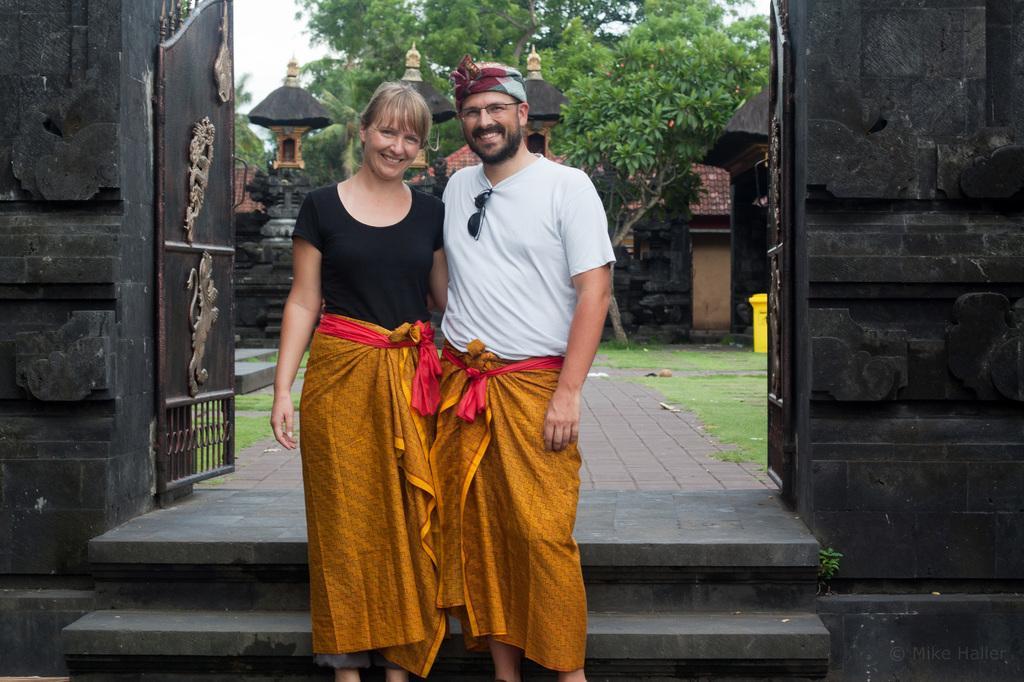How would you summarize this image in a sentence or two? In this image I can see two people with different color dresses. In the background I can see the metal gate and the wall. I can also see the poles, many trees and the sky. 